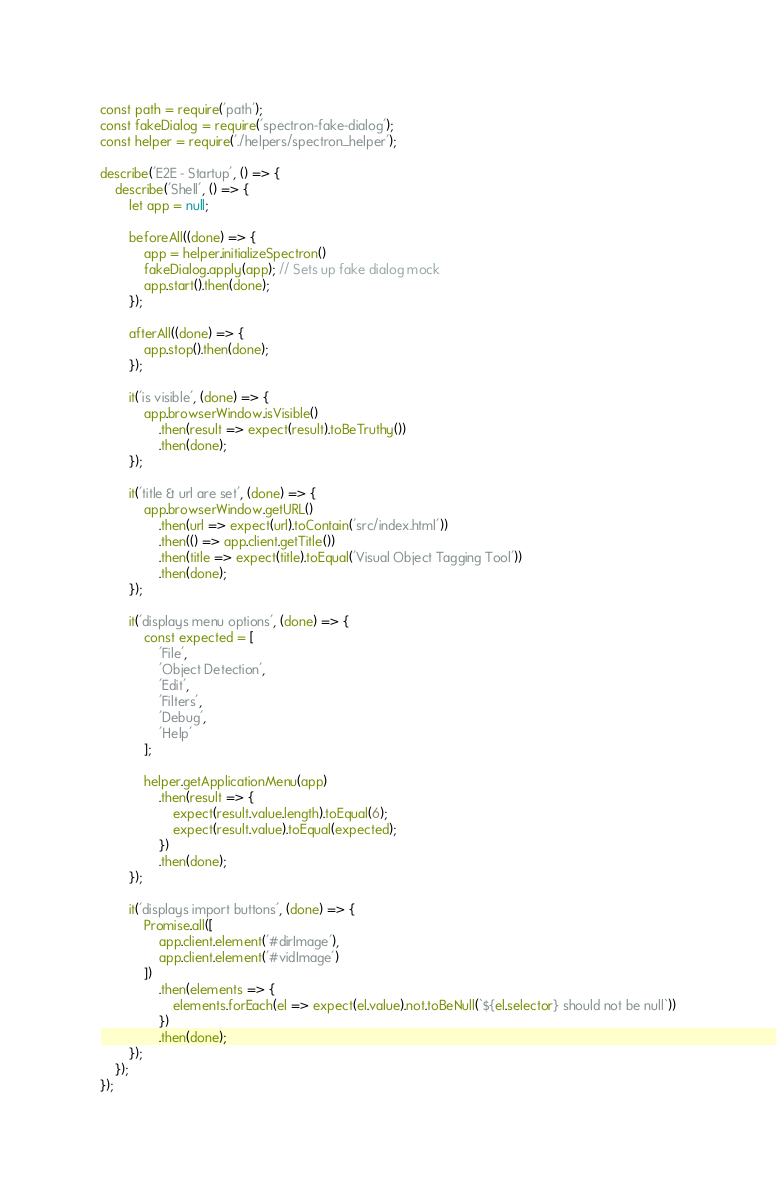Convert code to text. <code><loc_0><loc_0><loc_500><loc_500><_JavaScript_>const path = require('path');
const fakeDialog = require('spectron-fake-dialog');
const helper = require('./helpers/spectron_helper');

describe('E2E - Startup', () => {
    describe('Shell', () => {
        let app = null;

        beforeAll((done) => {
            app = helper.initializeSpectron()
            fakeDialog.apply(app); // Sets up fake dialog mock
            app.start().then(done);
        });

        afterAll((done) => {
            app.stop().then(done);
        });

        it('is visible', (done) => {
            app.browserWindow.isVisible()
                .then(result => expect(result).toBeTruthy())
                .then(done);
        });

        it('title & url are set', (done) => {
            app.browserWindow.getURL()
                .then(url => expect(url).toContain('src/index.html'))
                .then(() => app.client.getTitle())
                .then(title => expect(title).toEqual('Visual Object Tagging Tool'))
                .then(done);
        });

        it('displays menu options', (done) => {
            const expected = [
                'File',
                'Object Detection',
                'Edit',
                'Filters',
                'Debug',
                'Help'
            ];

            helper.getApplicationMenu(app)
                .then(result => {
                    expect(result.value.length).toEqual(6);
                    expect(result.value).toEqual(expected);
                })
                .then(done);
        });

        it('displays import buttons', (done) => {
            Promise.all([
                app.client.element('#dirImage'),
                app.client.element('#vidImage')
            ])
                .then(elements => {
                    elements.forEach(el => expect(el.value).not.toBeNull(`${el.selector} should not be null`))
                })
                .then(done);
        });
    });
});</code> 